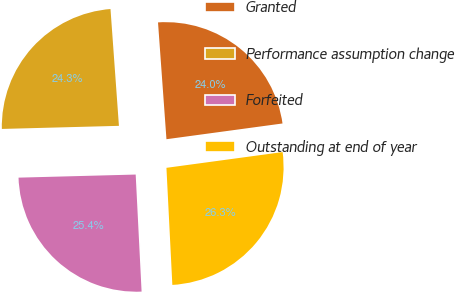<chart> <loc_0><loc_0><loc_500><loc_500><pie_chart><fcel>Granted<fcel>Performance assumption change<fcel>Forfeited<fcel>Outstanding at end of year<nl><fcel>24.0%<fcel>24.27%<fcel>25.38%<fcel>26.34%<nl></chart> 